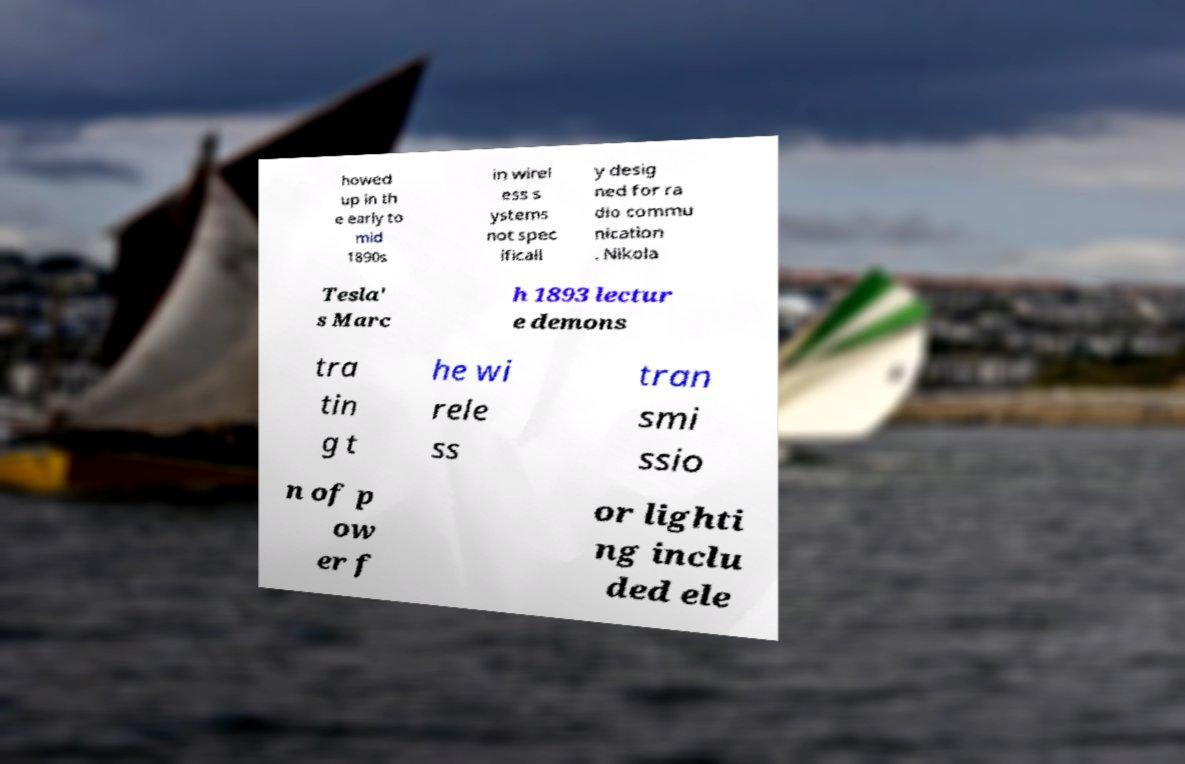There's text embedded in this image that I need extracted. Can you transcribe it verbatim? howed up in th e early to mid 1890s in wirel ess s ystems not spec ificall y desig ned for ra dio commu nication . Nikola Tesla' s Marc h 1893 lectur e demons tra tin g t he wi rele ss tran smi ssio n of p ow er f or lighti ng inclu ded ele 